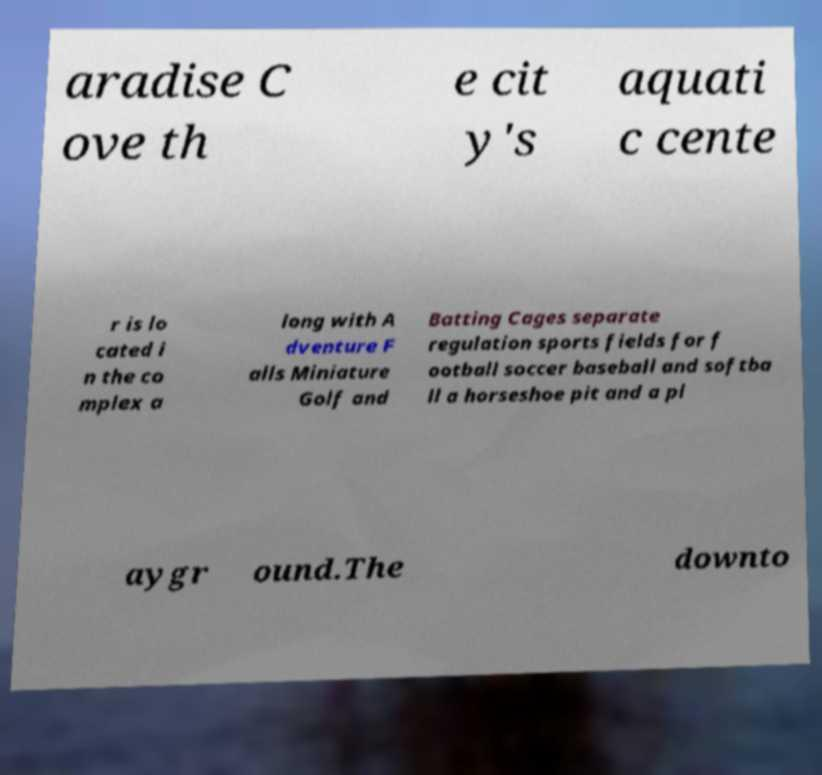Can you read and provide the text displayed in the image?This photo seems to have some interesting text. Can you extract and type it out for me? aradise C ove th e cit y's aquati c cente r is lo cated i n the co mplex a long with A dventure F alls Miniature Golf and Batting Cages separate regulation sports fields for f ootball soccer baseball and softba ll a horseshoe pit and a pl aygr ound.The downto 